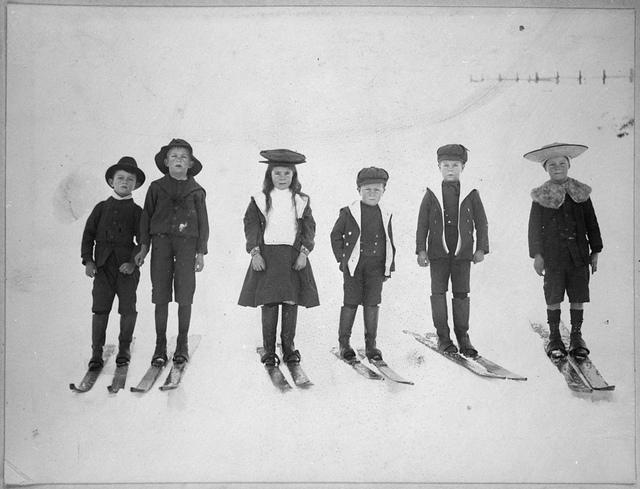How many children are in the picture?
Give a very brief answer. 6. How many people are there?
Give a very brief answer. 6. How many people are in the photo?
Give a very brief answer. 6. 